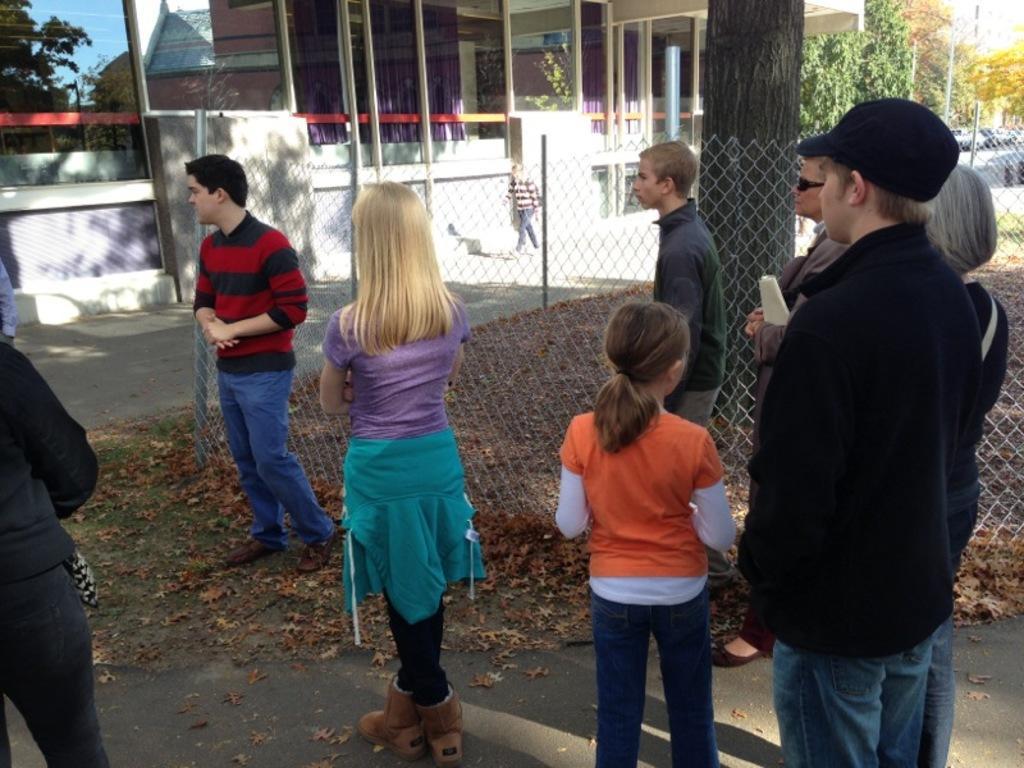Please provide a concise description of this image. At the front of the image there are few people are standing on the road. Behind them there is a fencing. Behind the fencing on the ground there are dry leaves and also there is a tree trunk. In the background there are few stores with glass windows and walls. And at the top right of the image there are trees. 